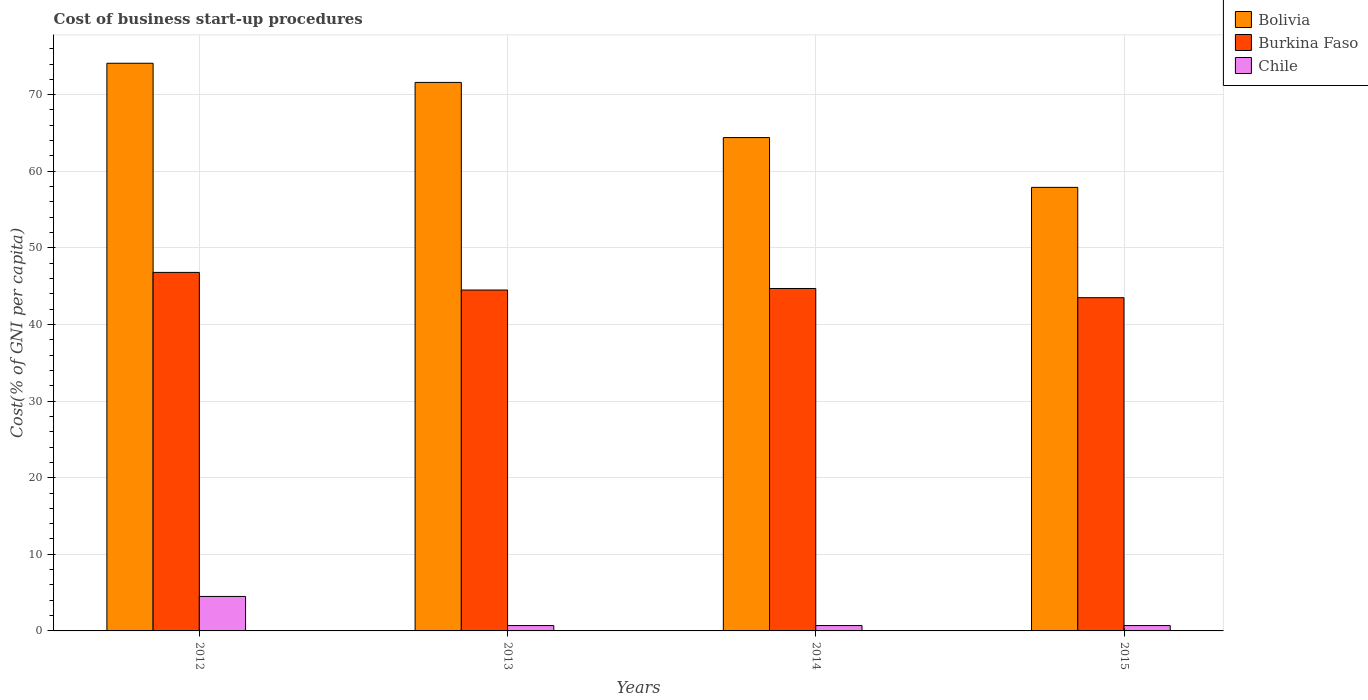Are the number of bars per tick equal to the number of legend labels?
Ensure brevity in your answer.  Yes. Are the number of bars on each tick of the X-axis equal?
Your response must be concise. Yes. How many bars are there on the 4th tick from the left?
Offer a very short reply. 3. What is the label of the 2nd group of bars from the left?
Provide a succinct answer. 2013. In how many cases, is the number of bars for a given year not equal to the number of legend labels?
Give a very brief answer. 0. What is the cost of business start-up procedures in Chile in 2014?
Ensure brevity in your answer.  0.7. Across all years, what is the maximum cost of business start-up procedures in Chile?
Your answer should be very brief. 4.5. Across all years, what is the minimum cost of business start-up procedures in Bolivia?
Provide a succinct answer. 57.9. In which year was the cost of business start-up procedures in Burkina Faso maximum?
Your answer should be very brief. 2012. In which year was the cost of business start-up procedures in Chile minimum?
Keep it short and to the point. 2013. What is the total cost of business start-up procedures in Burkina Faso in the graph?
Keep it short and to the point. 179.5. What is the difference between the cost of business start-up procedures in Bolivia in 2013 and that in 2015?
Ensure brevity in your answer.  13.7. What is the difference between the cost of business start-up procedures in Burkina Faso in 2014 and the cost of business start-up procedures in Chile in 2012?
Your answer should be very brief. 40.2. What is the average cost of business start-up procedures in Bolivia per year?
Provide a short and direct response. 67. In the year 2013, what is the difference between the cost of business start-up procedures in Chile and cost of business start-up procedures in Burkina Faso?
Offer a very short reply. -43.8. In how many years, is the cost of business start-up procedures in Bolivia greater than 50 %?
Give a very brief answer. 4. What is the ratio of the cost of business start-up procedures in Burkina Faso in 2012 to that in 2013?
Your answer should be compact. 1.05. What is the difference between the highest and the lowest cost of business start-up procedures in Bolivia?
Offer a terse response. 16.2. What does the 2nd bar from the left in 2013 represents?
Offer a terse response. Burkina Faso. What does the 3rd bar from the right in 2014 represents?
Offer a terse response. Bolivia. How many bars are there?
Keep it short and to the point. 12. How many years are there in the graph?
Keep it short and to the point. 4. What is the difference between two consecutive major ticks on the Y-axis?
Give a very brief answer. 10. Are the values on the major ticks of Y-axis written in scientific E-notation?
Offer a very short reply. No. Does the graph contain grids?
Give a very brief answer. Yes. How many legend labels are there?
Offer a very short reply. 3. How are the legend labels stacked?
Give a very brief answer. Vertical. What is the title of the graph?
Make the answer very short. Cost of business start-up procedures. What is the label or title of the Y-axis?
Your answer should be compact. Cost(% of GNI per capita). What is the Cost(% of GNI per capita) in Bolivia in 2012?
Offer a very short reply. 74.1. What is the Cost(% of GNI per capita) of Burkina Faso in 2012?
Ensure brevity in your answer.  46.8. What is the Cost(% of GNI per capita) of Chile in 2012?
Give a very brief answer. 4.5. What is the Cost(% of GNI per capita) in Bolivia in 2013?
Offer a terse response. 71.6. What is the Cost(% of GNI per capita) in Burkina Faso in 2013?
Your response must be concise. 44.5. What is the Cost(% of GNI per capita) of Chile in 2013?
Provide a succinct answer. 0.7. What is the Cost(% of GNI per capita) in Bolivia in 2014?
Offer a terse response. 64.4. What is the Cost(% of GNI per capita) in Burkina Faso in 2014?
Provide a short and direct response. 44.7. What is the Cost(% of GNI per capita) in Chile in 2014?
Your answer should be compact. 0.7. What is the Cost(% of GNI per capita) of Bolivia in 2015?
Your answer should be compact. 57.9. What is the Cost(% of GNI per capita) in Burkina Faso in 2015?
Your response must be concise. 43.5. Across all years, what is the maximum Cost(% of GNI per capita) of Bolivia?
Provide a succinct answer. 74.1. Across all years, what is the maximum Cost(% of GNI per capita) in Burkina Faso?
Make the answer very short. 46.8. Across all years, what is the maximum Cost(% of GNI per capita) in Chile?
Make the answer very short. 4.5. Across all years, what is the minimum Cost(% of GNI per capita) of Bolivia?
Offer a terse response. 57.9. Across all years, what is the minimum Cost(% of GNI per capita) in Burkina Faso?
Provide a succinct answer. 43.5. Across all years, what is the minimum Cost(% of GNI per capita) of Chile?
Your answer should be very brief. 0.7. What is the total Cost(% of GNI per capita) of Bolivia in the graph?
Your answer should be very brief. 268. What is the total Cost(% of GNI per capita) in Burkina Faso in the graph?
Provide a short and direct response. 179.5. What is the total Cost(% of GNI per capita) of Chile in the graph?
Make the answer very short. 6.6. What is the difference between the Cost(% of GNI per capita) of Burkina Faso in 2012 and that in 2013?
Make the answer very short. 2.3. What is the difference between the Cost(% of GNI per capita) in Bolivia in 2012 and that in 2014?
Offer a very short reply. 9.7. What is the difference between the Cost(% of GNI per capita) of Burkina Faso in 2012 and that in 2014?
Your answer should be very brief. 2.1. What is the difference between the Cost(% of GNI per capita) of Chile in 2012 and that in 2014?
Ensure brevity in your answer.  3.8. What is the difference between the Cost(% of GNI per capita) of Burkina Faso in 2012 and that in 2015?
Your answer should be compact. 3.3. What is the difference between the Cost(% of GNI per capita) of Chile in 2012 and that in 2015?
Provide a short and direct response. 3.8. What is the difference between the Cost(% of GNI per capita) of Chile in 2013 and that in 2014?
Keep it short and to the point. 0. What is the difference between the Cost(% of GNI per capita) in Bolivia in 2013 and that in 2015?
Your answer should be very brief. 13.7. What is the difference between the Cost(% of GNI per capita) in Chile in 2013 and that in 2015?
Your answer should be very brief. 0. What is the difference between the Cost(% of GNI per capita) of Bolivia in 2014 and that in 2015?
Your answer should be very brief. 6.5. What is the difference between the Cost(% of GNI per capita) in Burkina Faso in 2014 and that in 2015?
Give a very brief answer. 1.2. What is the difference between the Cost(% of GNI per capita) in Bolivia in 2012 and the Cost(% of GNI per capita) in Burkina Faso in 2013?
Provide a short and direct response. 29.6. What is the difference between the Cost(% of GNI per capita) in Bolivia in 2012 and the Cost(% of GNI per capita) in Chile in 2013?
Offer a terse response. 73.4. What is the difference between the Cost(% of GNI per capita) of Burkina Faso in 2012 and the Cost(% of GNI per capita) of Chile in 2013?
Keep it short and to the point. 46.1. What is the difference between the Cost(% of GNI per capita) in Bolivia in 2012 and the Cost(% of GNI per capita) in Burkina Faso in 2014?
Your response must be concise. 29.4. What is the difference between the Cost(% of GNI per capita) of Bolivia in 2012 and the Cost(% of GNI per capita) of Chile in 2014?
Ensure brevity in your answer.  73.4. What is the difference between the Cost(% of GNI per capita) in Burkina Faso in 2012 and the Cost(% of GNI per capita) in Chile in 2014?
Offer a very short reply. 46.1. What is the difference between the Cost(% of GNI per capita) in Bolivia in 2012 and the Cost(% of GNI per capita) in Burkina Faso in 2015?
Your answer should be compact. 30.6. What is the difference between the Cost(% of GNI per capita) of Bolivia in 2012 and the Cost(% of GNI per capita) of Chile in 2015?
Your answer should be very brief. 73.4. What is the difference between the Cost(% of GNI per capita) in Burkina Faso in 2012 and the Cost(% of GNI per capita) in Chile in 2015?
Offer a terse response. 46.1. What is the difference between the Cost(% of GNI per capita) of Bolivia in 2013 and the Cost(% of GNI per capita) of Burkina Faso in 2014?
Your response must be concise. 26.9. What is the difference between the Cost(% of GNI per capita) in Bolivia in 2013 and the Cost(% of GNI per capita) in Chile in 2014?
Ensure brevity in your answer.  70.9. What is the difference between the Cost(% of GNI per capita) in Burkina Faso in 2013 and the Cost(% of GNI per capita) in Chile in 2014?
Keep it short and to the point. 43.8. What is the difference between the Cost(% of GNI per capita) of Bolivia in 2013 and the Cost(% of GNI per capita) of Burkina Faso in 2015?
Provide a succinct answer. 28.1. What is the difference between the Cost(% of GNI per capita) of Bolivia in 2013 and the Cost(% of GNI per capita) of Chile in 2015?
Keep it short and to the point. 70.9. What is the difference between the Cost(% of GNI per capita) in Burkina Faso in 2013 and the Cost(% of GNI per capita) in Chile in 2015?
Offer a terse response. 43.8. What is the difference between the Cost(% of GNI per capita) in Bolivia in 2014 and the Cost(% of GNI per capita) in Burkina Faso in 2015?
Offer a terse response. 20.9. What is the difference between the Cost(% of GNI per capita) of Bolivia in 2014 and the Cost(% of GNI per capita) of Chile in 2015?
Your answer should be very brief. 63.7. What is the difference between the Cost(% of GNI per capita) in Burkina Faso in 2014 and the Cost(% of GNI per capita) in Chile in 2015?
Make the answer very short. 44. What is the average Cost(% of GNI per capita) of Bolivia per year?
Give a very brief answer. 67. What is the average Cost(% of GNI per capita) in Burkina Faso per year?
Offer a very short reply. 44.88. What is the average Cost(% of GNI per capita) of Chile per year?
Provide a short and direct response. 1.65. In the year 2012, what is the difference between the Cost(% of GNI per capita) in Bolivia and Cost(% of GNI per capita) in Burkina Faso?
Your answer should be compact. 27.3. In the year 2012, what is the difference between the Cost(% of GNI per capita) in Bolivia and Cost(% of GNI per capita) in Chile?
Offer a terse response. 69.6. In the year 2012, what is the difference between the Cost(% of GNI per capita) in Burkina Faso and Cost(% of GNI per capita) in Chile?
Your response must be concise. 42.3. In the year 2013, what is the difference between the Cost(% of GNI per capita) in Bolivia and Cost(% of GNI per capita) in Burkina Faso?
Your answer should be compact. 27.1. In the year 2013, what is the difference between the Cost(% of GNI per capita) in Bolivia and Cost(% of GNI per capita) in Chile?
Make the answer very short. 70.9. In the year 2013, what is the difference between the Cost(% of GNI per capita) in Burkina Faso and Cost(% of GNI per capita) in Chile?
Give a very brief answer. 43.8. In the year 2014, what is the difference between the Cost(% of GNI per capita) in Bolivia and Cost(% of GNI per capita) in Burkina Faso?
Provide a short and direct response. 19.7. In the year 2014, what is the difference between the Cost(% of GNI per capita) in Bolivia and Cost(% of GNI per capita) in Chile?
Offer a very short reply. 63.7. In the year 2014, what is the difference between the Cost(% of GNI per capita) of Burkina Faso and Cost(% of GNI per capita) of Chile?
Your answer should be compact. 44. In the year 2015, what is the difference between the Cost(% of GNI per capita) in Bolivia and Cost(% of GNI per capita) in Burkina Faso?
Provide a short and direct response. 14.4. In the year 2015, what is the difference between the Cost(% of GNI per capita) of Bolivia and Cost(% of GNI per capita) of Chile?
Make the answer very short. 57.2. In the year 2015, what is the difference between the Cost(% of GNI per capita) of Burkina Faso and Cost(% of GNI per capita) of Chile?
Make the answer very short. 42.8. What is the ratio of the Cost(% of GNI per capita) in Bolivia in 2012 to that in 2013?
Make the answer very short. 1.03. What is the ratio of the Cost(% of GNI per capita) in Burkina Faso in 2012 to that in 2013?
Give a very brief answer. 1.05. What is the ratio of the Cost(% of GNI per capita) of Chile in 2012 to that in 2013?
Your response must be concise. 6.43. What is the ratio of the Cost(% of GNI per capita) of Bolivia in 2012 to that in 2014?
Your answer should be compact. 1.15. What is the ratio of the Cost(% of GNI per capita) in Burkina Faso in 2012 to that in 2014?
Give a very brief answer. 1.05. What is the ratio of the Cost(% of GNI per capita) in Chile in 2012 to that in 2014?
Make the answer very short. 6.43. What is the ratio of the Cost(% of GNI per capita) in Bolivia in 2012 to that in 2015?
Give a very brief answer. 1.28. What is the ratio of the Cost(% of GNI per capita) in Burkina Faso in 2012 to that in 2015?
Make the answer very short. 1.08. What is the ratio of the Cost(% of GNI per capita) of Chile in 2012 to that in 2015?
Offer a very short reply. 6.43. What is the ratio of the Cost(% of GNI per capita) in Bolivia in 2013 to that in 2014?
Give a very brief answer. 1.11. What is the ratio of the Cost(% of GNI per capita) of Burkina Faso in 2013 to that in 2014?
Provide a short and direct response. 1. What is the ratio of the Cost(% of GNI per capita) of Bolivia in 2013 to that in 2015?
Offer a very short reply. 1.24. What is the ratio of the Cost(% of GNI per capita) of Chile in 2013 to that in 2015?
Offer a very short reply. 1. What is the ratio of the Cost(% of GNI per capita) of Bolivia in 2014 to that in 2015?
Your answer should be very brief. 1.11. What is the ratio of the Cost(% of GNI per capita) of Burkina Faso in 2014 to that in 2015?
Offer a very short reply. 1.03. What is the difference between the highest and the second highest Cost(% of GNI per capita) of Chile?
Give a very brief answer. 3.8. What is the difference between the highest and the lowest Cost(% of GNI per capita) of Burkina Faso?
Your response must be concise. 3.3. 